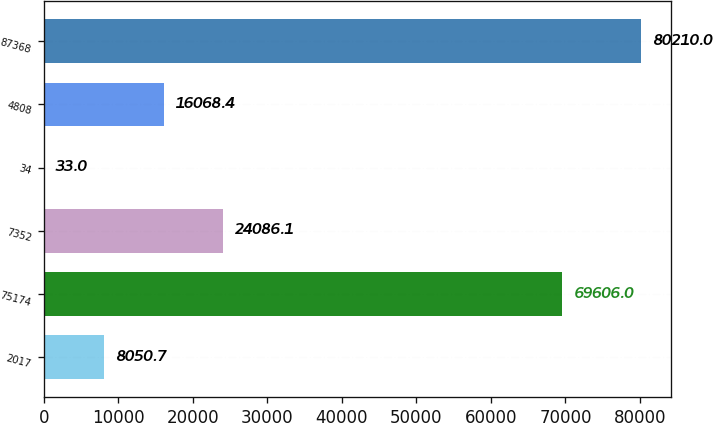Convert chart. <chart><loc_0><loc_0><loc_500><loc_500><bar_chart><fcel>2017<fcel>75174<fcel>7352<fcel>34<fcel>4808<fcel>87368<nl><fcel>8050.7<fcel>69606<fcel>24086.1<fcel>33<fcel>16068.4<fcel>80210<nl></chart> 